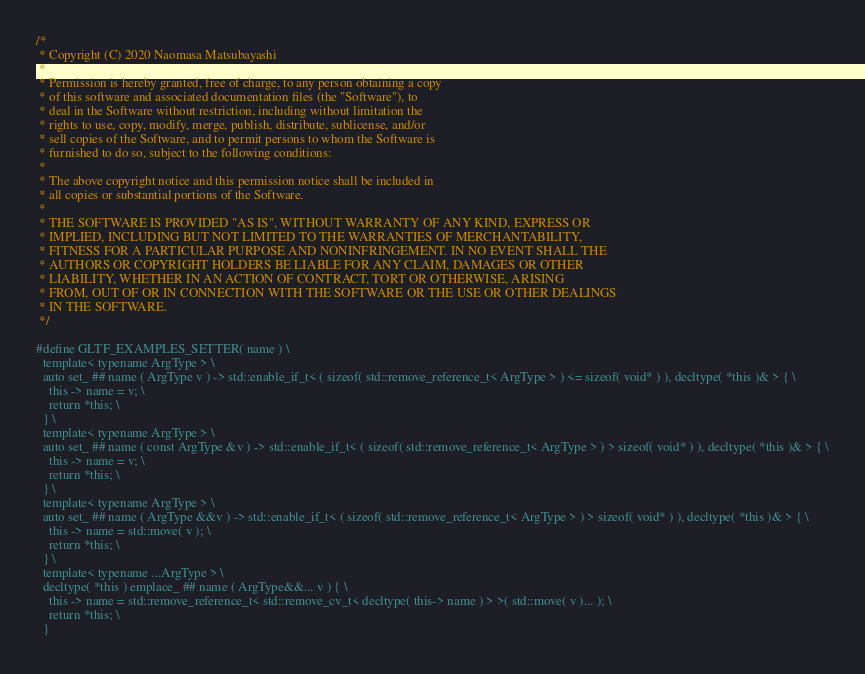<code> <loc_0><loc_0><loc_500><loc_500><_C_>/*
 * Copyright (C) 2020 Naomasa Matsubayashi
 *
 * Permission is hereby granted, free of charge, to any person obtaining a copy
 * of this software and associated documentation files (the "Software"), to
 * deal in the Software without restriction, including without limitation the
 * rights to use, copy, modify, merge, publish, distribute, sublicense, and/or
 * sell copies of the Software, and to permit persons to whom the Software is
 * furnished to do so, subject to the following conditions:
 *
 * The above copyright notice and this permission notice shall be included in
 * all copies or substantial portions of the Software.
 *
 * THE SOFTWARE IS PROVIDED "AS IS", WITHOUT WARRANTY OF ANY KIND, EXPRESS OR
 * IMPLIED, INCLUDING BUT NOT LIMITED TO THE WARRANTIES OF MERCHANTABILITY,
 * FITNESS FOR A PARTICULAR PURPOSE AND NONINFRINGEMENT. IN NO EVENT SHALL THE
 * AUTHORS OR COPYRIGHT HOLDERS BE LIABLE FOR ANY CLAIM, DAMAGES OR OTHER
 * LIABILITY, WHETHER IN AN ACTION OF CONTRACT, TORT OR OTHERWISE, ARISING
 * FROM, OUT OF OR IN CONNECTION WITH THE SOFTWARE OR THE USE OR OTHER DEALINGS
 * IN THE SOFTWARE.
 */

#define GLTF_EXAMPLES_SETTER( name ) \
  template< typename ArgType > \
  auto set_ ## name ( ArgType v ) -> std::enable_if_t< ( sizeof( std::remove_reference_t< ArgType > ) <= sizeof( void* ) ), decltype( *this )& > { \
    this -> name = v; \
    return *this; \
  } \
  template< typename ArgType > \
  auto set_ ## name ( const ArgType &v ) -> std::enable_if_t< ( sizeof( std::remove_reference_t< ArgType > ) > sizeof( void* ) ), decltype( *this )& > { \
    this -> name = v; \
    return *this; \
  } \
  template< typename ArgType > \
  auto set_ ## name ( ArgType &&v ) -> std::enable_if_t< ( sizeof( std::remove_reference_t< ArgType > ) > sizeof( void* ) ), decltype( *this )& > { \
    this -> name = std::move( v ); \
    return *this; \
  } \
  template< typename ...ArgType > \
  decltype( *this ) emplace_ ## name ( ArgType&&... v ) { \
    this -> name = std::remove_reference_t< std::remove_cv_t< decltype( this-> name ) > >( std::move( v )... ); \
    return *this; \
  }
</code> 